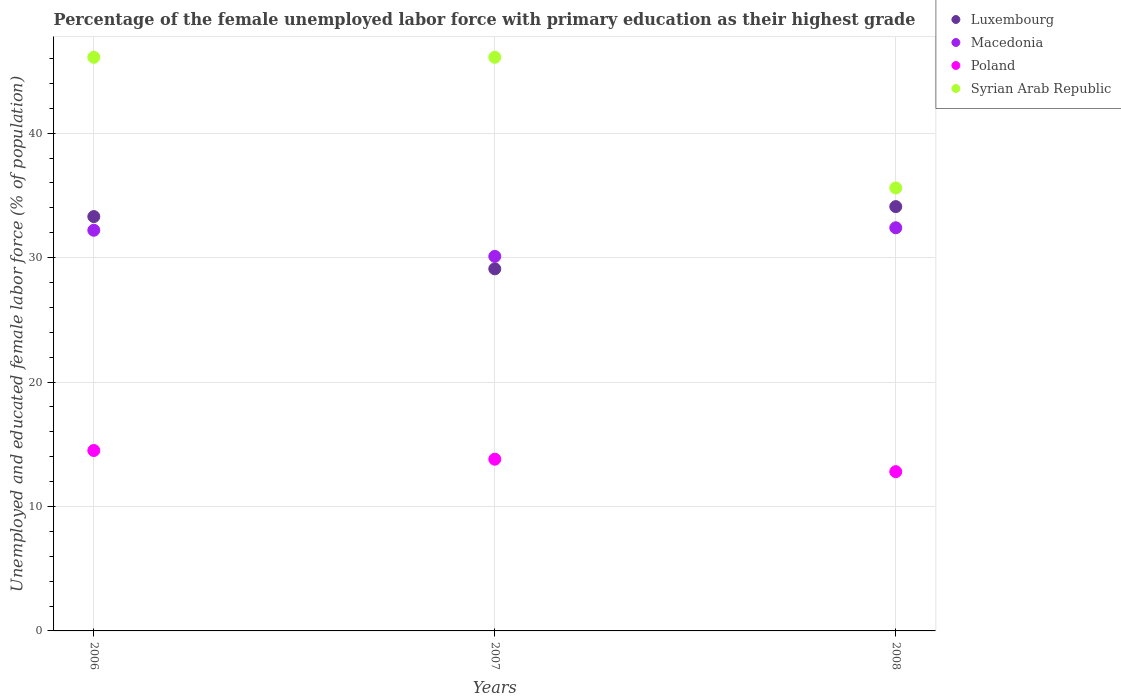Is the number of dotlines equal to the number of legend labels?
Your answer should be compact. Yes. What is the percentage of the unemployed female labor force with primary education in Syrian Arab Republic in 2007?
Your answer should be very brief. 46.1. Across all years, what is the maximum percentage of the unemployed female labor force with primary education in Poland?
Keep it short and to the point. 14.5. Across all years, what is the minimum percentage of the unemployed female labor force with primary education in Macedonia?
Your answer should be very brief. 30.1. In which year was the percentage of the unemployed female labor force with primary education in Syrian Arab Republic maximum?
Make the answer very short. 2006. What is the total percentage of the unemployed female labor force with primary education in Macedonia in the graph?
Keep it short and to the point. 94.7. What is the difference between the percentage of the unemployed female labor force with primary education in Syrian Arab Republic in 2006 and that in 2007?
Offer a terse response. 0. What is the average percentage of the unemployed female labor force with primary education in Macedonia per year?
Your answer should be very brief. 31.57. In the year 2007, what is the difference between the percentage of the unemployed female labor force with primary education in Luxembourg and percentage of the unemployed female labor force with primary education in Macedonia?
Your response must be concise. -1. What is the ratio of the percentage of the unemployed female labor force with primary education in Luxembourg in 2006 to that in 2008?
Offer a very short reply. 0.98. Is the difference between the percentage of the unemployed female labor force with primary education in Luxembourg in 2007 and 2008 greater than the difference between the percentage of the unemployed female labor force with primary education in Macedonia in 2007 and 2008?
Keep it short and to the point. No. What is the difference between the highest and the second highest percentage of the unemployed female labor force with primary education in Syrian Arab Republic?
Your answer should be very brief. 0. What is the difference between the highest and the lowest percentage of the unemployed female labor force with primary education in Poland?
Provide a succinct answer. 1.7. In how many years, is the percentage of the unemployed female labor force with primary education in Syrian Arab Republic greater than the average percentage of the unemployed female labor force with primary education in Syrian Arab Republic taken over all years?
Give a very brief answer. 2. Is it the case that in every year, the sum of the percentage of the unemployed female labor force with primary education in Poland and percentage of the unemployed female labor force with primary education in Macedonia  is greater than the sum of percentage of the unemployed female labor force with primary education in Syrian Arab Republic and percentage of the unemployed female labor force with primary education in Luxembourg?
Make the answer very short. No. Does the percentage of the unemployed female labor force with primary education in Macedonia monotonically increase over the years?
Your answer should be very brief. No. Is the percentage of the unemployed female labor force with primary education in Luxembourg strictly greater than the percentage of the unemployed female labor force with primary education in Macedonia over the years?
Make the answer very short. No. Are the values on the major ticks of Y-axis written in scientific E-notation?
Give a very brief answer. No. Does the graph contain grids?
Offer a terse response. Yes. What is the title of the graph?
Provide a succinct answer. Percentage of the female unemployed labor force with primary education as their highest grade. Does "Malta" appear as one of the legend labels in the graph?
Offer a terse response. No. What is the label or title of the Y-axis?
Ensure brevity in your answer.  Unemployed and educated female labor force (% of population). What is the Unemployed and educated female labor force (% of population) in Luxembourg in 2006?
Your answer should be very brief. 33.3. What is the Unemployed and educated female labor force (% of population) in Macedonia in 2006?
Keep it short and to the point. 32.2. What is the Unemployed and educated female labor force (% of population) of Poland in 2006?
Ensure brevity in your answer.  14.5. What is the Unemployed and educated female labor force (% of population) in Syrian Arab Republic in 2006?
Make the answer very short. 46.1. What is the Unemployed and educated female labor force (% of population) of Luxembourg in 2007?
Make the answer very short. 29.1. What is the Unemployed and educated female labor force (% of population) in Macedonia in 2007?
Provide a short and direct response. 30.1. What is the Unemployed and educated female labor force (% of population) in Poland in 2007?
Provide a succinct answer. 13.8. What is the Unemployed and educated female labor force (% of population) of Syrian Arab Republic in 2007?
Offer a very short reply. 46.1. What is the Unemployed and educated female labor force (% of population) in Luxembourg in 2008?
Provide a succinct answer. 34.1. What is the Unemployed and educated female labor force (% of population) of Macedonia in 2008?
Ensure brevity in your answer.  32.4. What is the Unemployed and educated female labor force (% of population) in Poland in 2008?
Ensure brevity in your answer.  12.8. What is the Unemployed and educated female labor force (% of population) of Syrian Arab Republic in 2008?
Your answer should be compact. 35.6. Across all years, what is the maximum Unemployed and educated female labor force (% of population) in Luxembourg?
Your answer should be very brief. 34.1. Across all years, what is the maximum Unemployed and educated female labor force (% of population) in Macedonia?
Give a very brief answer. 32.4. Across all years, what is the maximum Unemployed and educated female labor force (% of population) of Syrian Arab Republic?
Ensure brevity in your answer.  46.1. Across all years, what is the minimum Unemployed and educated female labor force (% of population) of Luxembourg?
Your answer should be very brief. 29.1. Across all years, what is the minimum Unemployed and educated female labor force (% of population) in Macedonia?
Ensure brevity in your answer.  30.1. Across all years, what is the minimum Unemployed and educated female labor force (% of population) of Poland?
Provide a succinct answer. 12.8. Across all years, what is the minimum Unemployed and educated female labor force (% of population) of Syrian Arab Republic?
Provide a succinct answer. 35.6. What is the total Unemployed and educated female labor force (% of population) of Luxembourg in the graph?
Keep it short and to the point. 96.5. What is the total Unemployed and educated female labor force (% of population) in Macedonia in the graph?
Provide a short and direct response. 94.7. What is the total Unemployed and educated female labor force (% of population) in Poland in the graph?
Offer a very short reply. 41.1. What is the total Unemployed and educated female labor force (% of population) of Syrian Arab Republic in the graph?
Offer a terse response. 127.8. What is the difference between the Unemployed and educated female labor force (% of population) in Luxembourg in 2006 and that in 2007?
Offer a terse response. 4.2. What is the difference between the Unemployed and educated female labor force (% of population) of Macedonia in 2006 and that in 2007?
Provide a succinct answer. 2.1. What is the difference between the Unemployed and educated female labor force (% of population) of Poland in 2006 and that in 2007?
Your answer should be very brief. 0.7. What is the difference between the Unemployed and educated female labor force (% of population) in Syrian Arab Republic in 2006 and that in 2007?
Provide a short and direct response. 0. What is the difference between the Unemployed and educated female labor force (% of population) of Macedonia in 2006 and that in 2008?
Your response must be concise. -0.2. What is the difference between the Unemployed and educated female labor force (% of population) in Poland in 2006 and that in 2008?
Provide a succinct answer. 1.7. What is the difference between the Unemployed and educated female labor force (% of population) of Macedonia in 2007 and that in 2008?
Give a very brief answer. -2.3. What is the difference between the Unemployed and educated female labor force (% of population) in Poland in 2007 and that in 2008?
Give a very brief answer. 1. What is the difference between the Unemployed and educated female labor force (% of population) of Luxembourg in 2006 and the Unemployed and educated female labor force (% of population) of Poland in 2007?
Keep it short and to the point. 19.5. What is the difference between the Unemployed and educated female labor force (% of population) of Poland in 2006 and the Unemployed and educated female labor force (% of population) of Syrian Arab Republic in 2007?
Make the answer very short. -31.6. What is the difference between the Unemployed and educated female labor force (% of population) in Luxembourg in 2006 and the Unemployed and educated female labor force (% of population) in Macedonia in 2008?
Give a very brief answer. 0.9. What is the difference between the Unemployed and educated female labor force (% of population) of Luxembourg in 2006 and the Unemployed and educated female labor force (% of population) of Syrian Arab Republic in 2008?
Give a very brief answer. -2.3. What is the difference between the Unemployed and educated female labor force (% of population) of Macedonia in 2006 and the Unemployed and educated female labor force (% of population) of Syrian Arab Republic in 2008?
Your response must be concise. -3.4. What is the difference between the Unemployed and educated female labor force (% of population) of Poland in 2006 and the Unemployed and educated female labor force (% of population) of Syrian Arab Republic in 2008?
Your answer should be compact. -21.1. What is the difference between the Unemployed and educated female labor force (% of population) of Luxembourg in 2007 and the Unemployed and educated female labor force (% of population) of Poland in 2008?
Make the answer very short. 16.3. What is the difference between the Unemployed and educated female labor force (% of population) in Macedonia in 2007 and the Unemployed and educated female labor force (% of population) in Poland in 2008?
Provide a succinct answer. 17.3. What is the difference between the Unemployed and educated female labor force (% of population) in Macedonia in 2007 and the Unemployed and educated female labor force (% of population) in Syrian Arab Republic in 2008?
Offer a terse response. -5.5. What is the difference between the Unemployed and educated female labor force (% of population) of Poland in 2007 and the Unemployed and educated female labor force (% of population) of Syrian Arab Republic in 2008?
Keep it short and to the point. -21.8. What is the average Unemployed and educated female labor force (% of population) in Luxembourg per year?
Give a very brief answer. 32.17. What is the average Unemployed and educated female labor force (% of population) in Macedonia per year?
Your answer should be very brief. 31.57. What is the average Unemployed and educated female labor force (% of population) of Poland per year?
Your response must be concise. 13.7. What is the average Unemployed and educated female labor force (% of population) of Syrian Arab Republic per year?
Offer a very short reply. 42.6. In the year 2006, what is the difference between the Unemployed and educated female labor force (% of population) of Luxembourg and Unemployed and educated female labor force (% of population) of Syrian Arab Republic?
Provide a succinct answer. -12.8. In the year 2006, what is the difference between the Unemployed and educated female labor force (% of population) in Macedonia and Unemployed and educated female labor force (% of population) in Poland?
Your response must be concise. 17.7. In the year 2006, what is the difference between the Unemployed and educated female labor force (% of population) of Poland and Unemployed and educated female labor force (% of population) of Syrian Arab Republic?
Offer a very short reply. -31.6. In the year 2007, what is the difference between the Unemployed and educated female labor force (% of population) of Luxembourg and Unemployed and educated female labor force (% of population) of Macedonia?
Provide a succinct answer. -1. In the year 2007, what is the difference between the Unemployed and educated female labor force (% of population) in Luxembourg and Unemployed and educated female labor force (% of population) in Poland?
Provide a succinct answer. 15.3. In the year 2007, what is the difference between the Unemployed and educated female labor force (% of population) in Macedonia and Unemployed and educated female labor force (% of population) in Syrian Arab Republic?
Ensure brevity in your answer.  -16. In the year 2007, what is the difference between the Unemployed and educated female labor force (% of population) in Poland and Unemployed and educated female labor force (% of population) in Syrian Arab Republic?
Provide a short and direct response. -32.3. In the year 2008, what is the difference between the Unemployed and educated female labor force (% of population) of Luxembourg and Unemployed and educated female labor force (% of population) of Macedonia?
Offer a terse response. 1.7. In the year 2008, what is the difference between the Unemployed and educated female labor force (% of population) in Luxembourg and Unemployed and educated female labor force (% of population) in Poland?
Your answer should be very brief. 21.3. In the year 2008, what is the difference between the Unemployed and educated female labor force (% of population) in Luxembourg and Unemployed and educated female labor force (% of population) in Syrian Arab Republic?
Your answer should be very brief. -1.5. In the year 2008, what is the difference between the Unemployed and educated female labor force (% of population) in Macedonia and Unemployed and educated female labor force (% of population) in Poland?
Keep it short and to the point. 19.6. In the year 2008, what is the difference between the Unemployed and educated female labor force (% of population) in Poland and Unemployed and educated female labor force (% of population) in Syrian Arab Republic?
Ensure brevity in your answer.  -22.8. What is the ratio of the Unemployed and educated female labor force (% of population) of Luxembourg in 2006 to that in 2007?
Keep it short and to the point. 1.14. What is the ratio of the Unemployed and educated female labor force (% of population) in Macedonia in 2006 to that in 2007?
Make the answer very short. 1.07. What is the ratio of the Unemployed and educated female labor force (% of population) of Poland in 2006 to that in 2007?
Ensure brevity in your answer.  1.05. What is the ratio of the Unemployed and educated female labor force (% of population) in Syrian Arab Republic in 2006 to that in 2007?
Keep it short and to the point. 1. What is the ratio of the Unemployed and educated female labor force (% of population) of Luxembourg in 2006 to that in 2008?
Ensure brevity in your answer.  0.98. What is the ratio of the Unemployed and educated female labor force (% of population) in Poland in 2006 to that in 2008?
Ensure brevity in your answer.  1.13. What is the ratio of the Unemployed and educated female labor force (% of population) in Syrian Arab Republic in 2006 to that in 2008?
Your response must be concise. 1.29. What is the ratio of the Unemployed and educated female labor force (% of population) in Luxembourg in 2007 to that in 2008?
Your answer should be compact. 0.85. What is the ratio of the Unemployed and educated female labor force (% of population) of Macedonia in 2007 to that in 2008?
Ensure brevity in your answer.  0.93. What is the ratio of the Unemployed and educated female labor force (% of population) in Poland in 2007 to that in 2008?
Ensure brevity in your answer.  1.08. What is the ratio of the Unemployed and educated female labor force (% of population) of Syrian Arab Republic in 2007 to that in 2008?
Your answer should be compact. 1.29. What is the difference between the highest and the second highest Unemployed and educated female labor force (% of population) of Syrian Arab Republic?
Give a very brief answer. 0. What is the difference between the highest and the lowest Unemployed and educated female labor force (% of population) of Luxembourg?
Provide a short and direct response. 5. What is the difference between the highest and the lowest Unemployed and educated female labor force (% of population) in Poland?
Offer a terse response. 1.7. What is the difference between the highest and the lowest Unemployed and educated female labor force (% of population) in Syrian Arab Republic?
Give a very brief answer. 10.5. 